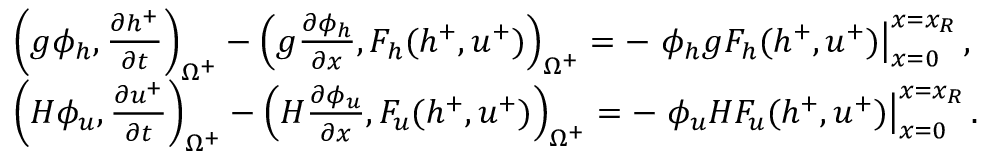<formula> <loc_0><loc_0><loc_500><loc_500>\begin{array} { r l } & { \left ( g \phi _ { h } , \frac { \partial h ^ { + } } { \partial t } \right ) _ { \Omega ^ { + } } - \left ( g \frac { \partial \phi _ { h } } { \partial x } , F _ { h } ( h ^ { + } , u ^ { + } ) \right ) _ { \Omega ^ { + } } = - \phi _ { h } g F _ { h } ( h ^ { + } , u ^ { + } ) \right | _ { x = 0 } ^ { x = x _ { R } } , } \\ & { \left ( H \phi _ { u } , \frac { \partial u ^ { + } } { \partial t } \right ) _ { \Omega ^ { + } } - \left ( H \frac { \partial \phi _ { u } } { \partial x } , F _ { u } ( h ^ { + } , u ^ { + } ) \right ) _ { \Omega ^ { + } } = - \phi _ { u } H F _ { u } ( h ^ { + } , u ^ { + } ) \right | _ { x = 0 } ^ { x = x _ { R } } . } \end{array}</formula> 